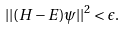<formula> <loc_0><loc_0><loc_500><loc_500>| | ( H - E ) \psi | | ^ { 2 } < \epsilon .</formula> 